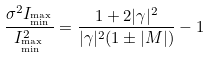<formula> <loc_0><loc_0><loc_500><loc_500>\frac { \sigma ^ { 2 } I _ { ^ { \max } _ { \min } } } { I _ { ^ { \max } _ { \min } } ^ { 2 } } = \frac { 1 + 2 | \gamma | ^ { 2 } } { | \gamma | ^ { 2 } ( 1 \pm | M | ) } - 1</formula> 